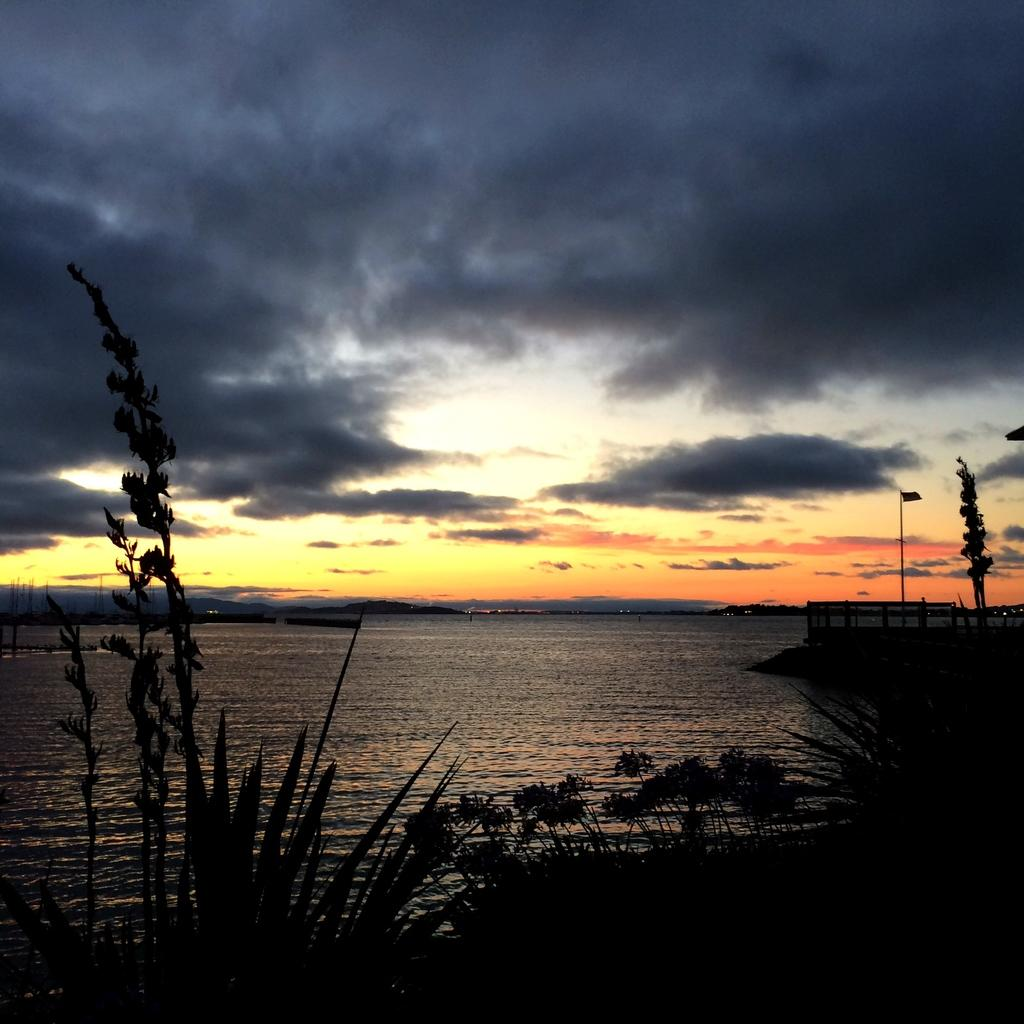What type of natural feature is at the bottom of the image? There is a river at the bottom of the image. What can be seen in the foreground of the image? There are plants in the foreground of the image. What structures are visible in the background of the image? There is a pole, a tree, and a fence in the background of the image. What is visible at the top of the image? The sky is visible at the top of the image. Can you tell me how many zebras are standing near the river in the image? There are no zebras present in the image; it features a river, plants, a pole, a tree, a fence, and the sky. What type of humor is being displayed by the tree in the image? There is no humor being displayed by the tree in the image; it is a stationary object in the background. 